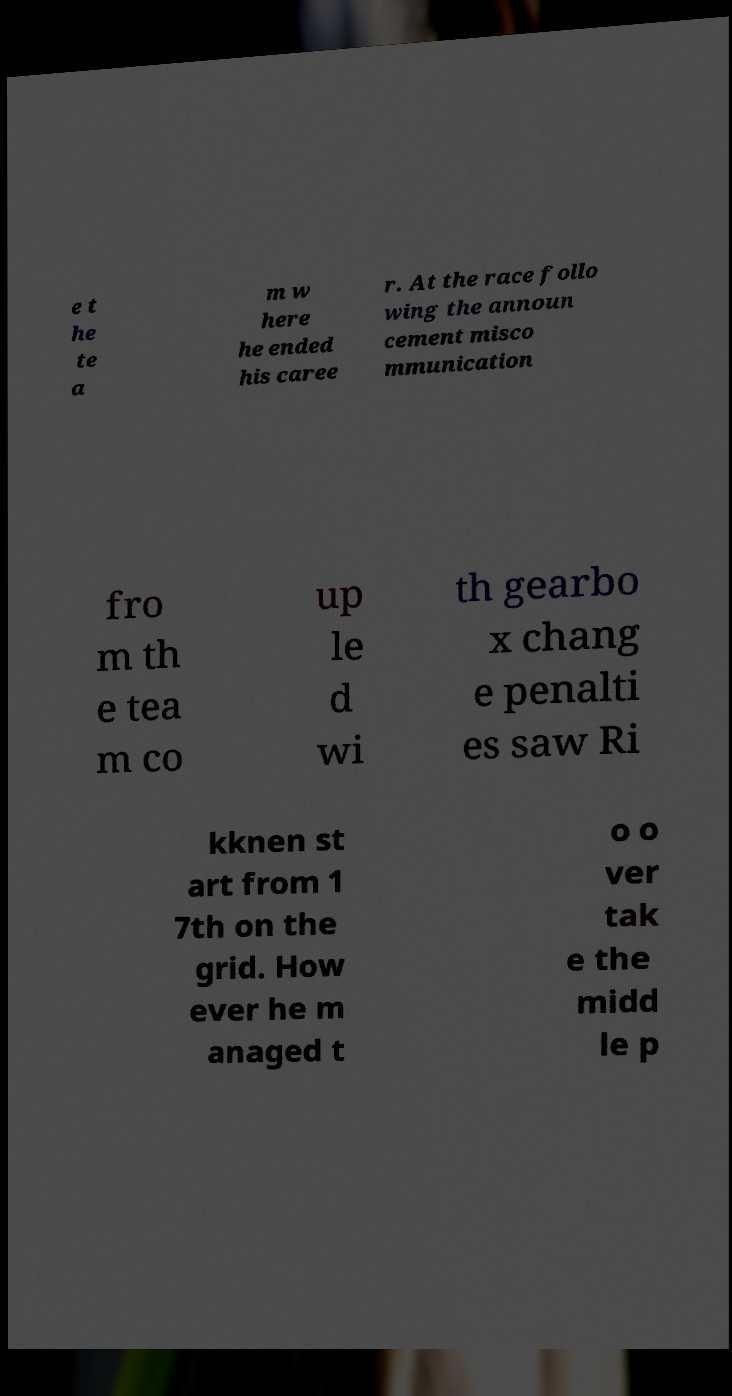What messages or text are displayed in this image? I need them in a readable, typed format. e t he te a m w here he ended his caree r. At the race follo wing the announ cement misco mmunication fro m th e tea m co up le d wi th gearbo x chang e penalti es saw Ri kknen st art from 1 7th on the grid. How ever he m anaged t o o ver tak e the midd le p 